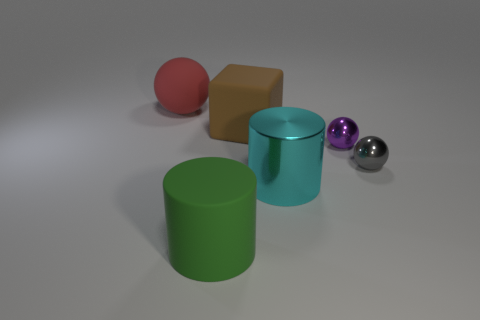Is the cyan object made of the same material as the big cylinder that is in front of the metallic cylinder?
Offer a terse response. No. Is the number of red spheres that are in front of the big cyan metallic cylinder less than the number of purple shiny balls behind the purple thing?
Give a very brief answer. No. There is a large cylinder to the left of the brown rubber thing; what material is it?
Ensure brevity in your answer.  Rubber. There is a object that is both to the left of the cyan object and in front of the tiny gray ball; what color is it?
Provide a succinct answer. Green. What number of other objects are the same color as the rubber block?
Ensure brevity in your answer.  0. The big object in front of the big shiny cylinder is what color?
Offer a terse response. Green. Is there a gray metallic sphere that has the same size as the purple metallic ball?
Keep it short and to the point. Yes. There is a red thing that is the same size as the brown matte block; what is its material?
Offer a terse response. Rubber. How many objects are either big things that are right of the large rubber cylinder or large objects that are left of the big shiny object?
Offer a very short reply. 4. Is there another matte object of the same shape as the tiny purple thing?
Your response must be concise. Yes. 